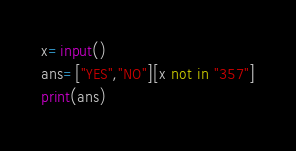Convert code to text. <code><loc_0><loc_0><loc_500><loc_500><_Python_>x=input()
ans=["YES","NO"][x not in "357"]
print(ans)</code> 